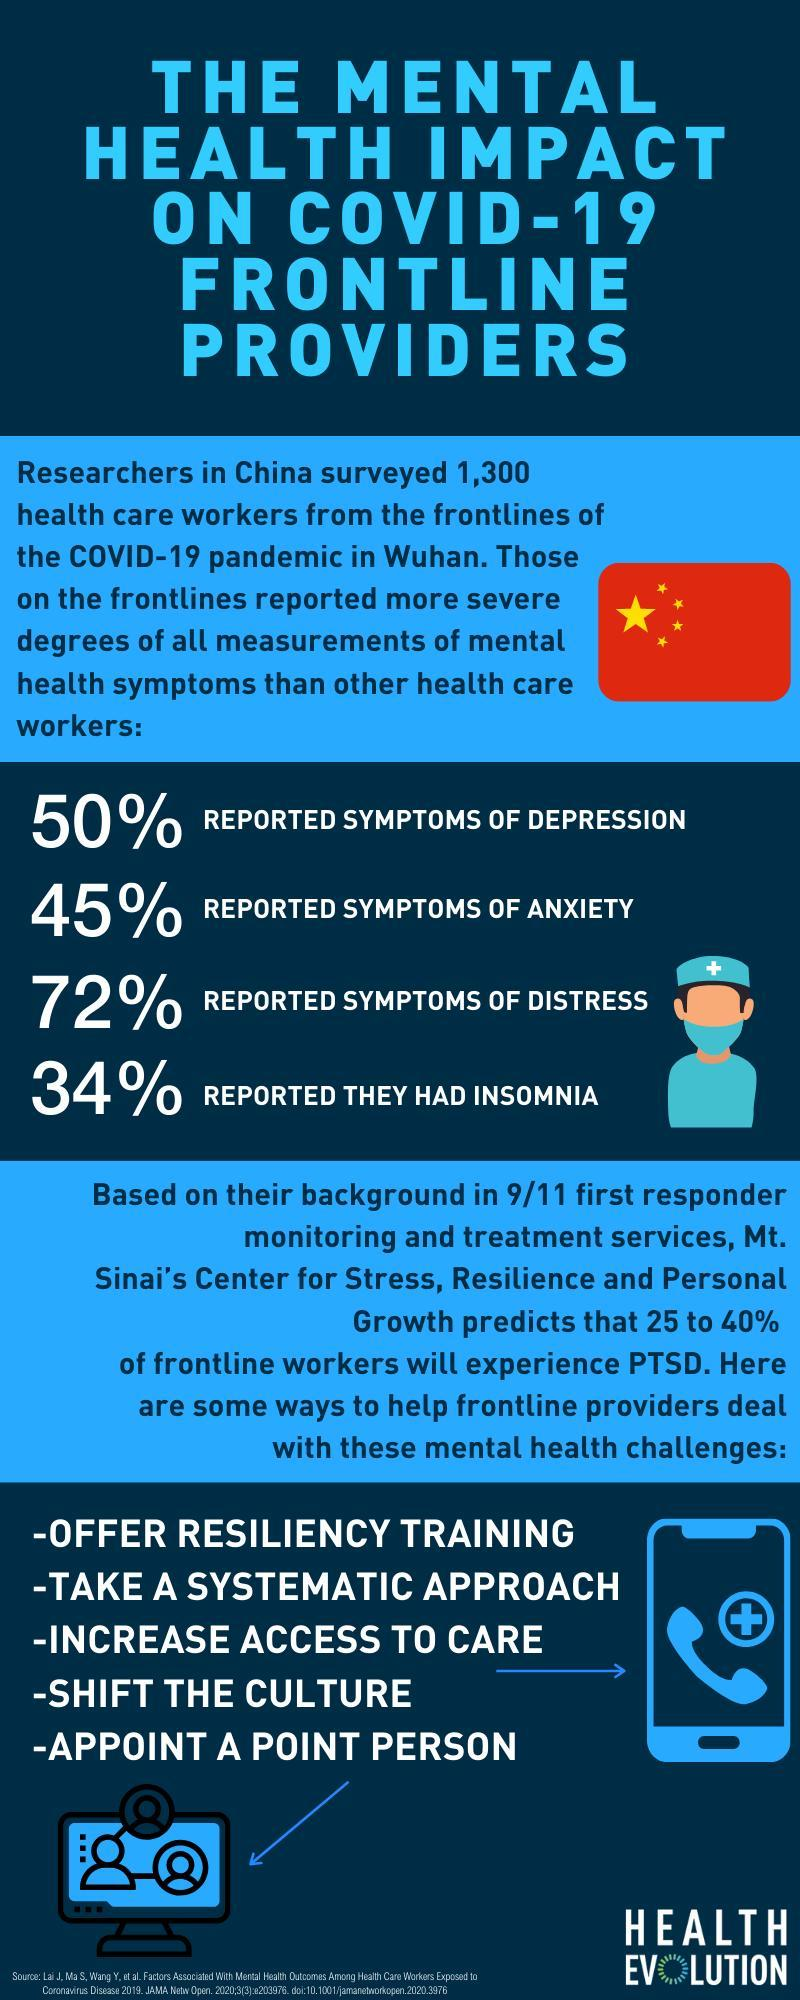What percentage of people have no symptoms of anxiety?
Answer the question with a short phrase. 55% What percentage of people have no symptoms of distress? 28% What percentage of people have no symptoms of insomnia? 66% What percentage of people have no symptoms of depression? 50% 